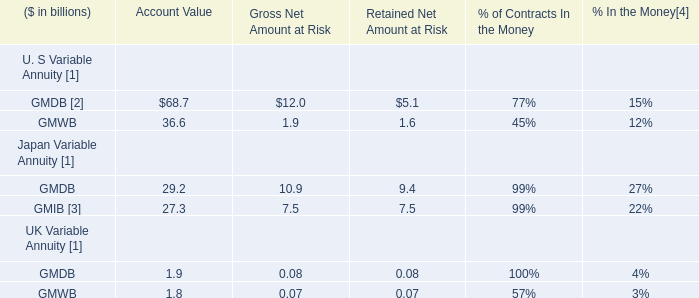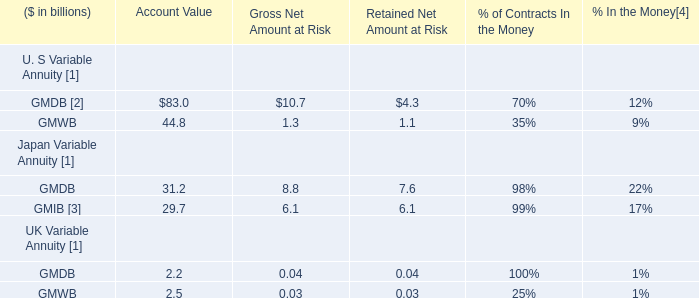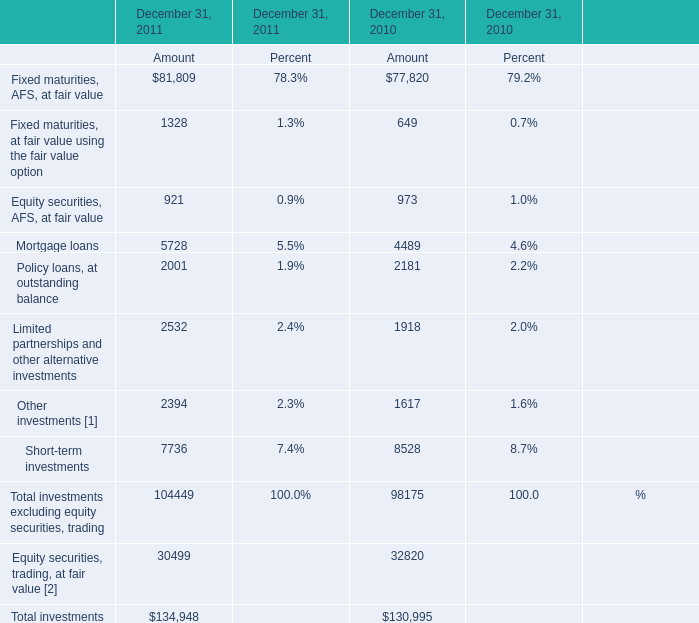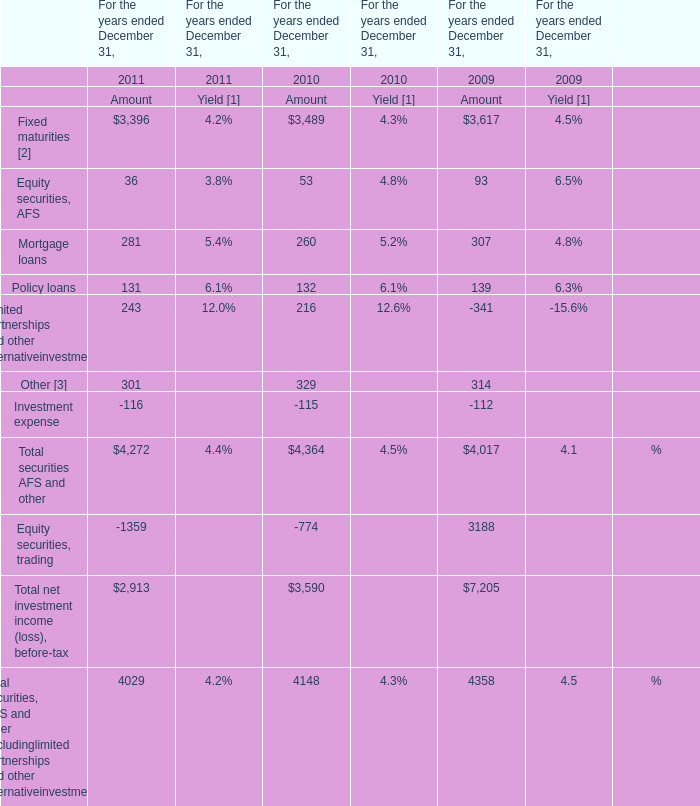What will Policy loans, at outstanding balance for Amount reach in 2012 if it continues to grow at its current rate? 
Computations: (2001 * (1 + ((2001 - 2181) / 2181)))
Answer: 1835.85557. 